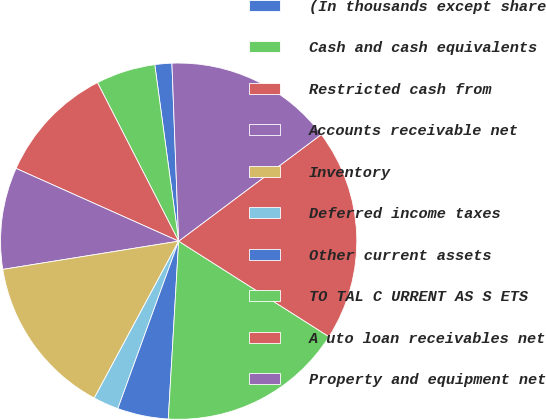<chart> <loc_0><loc_0><loc_500><loc_500><pie_chart><fcel>(In thousands except share<fcel>Cash and cash equivalents<fcel>Restricted cash from<fcel>Accounts receivable net<fcel>Inventory<fcel>Deferred income taxes<fcel>Other current assets<fcel>TO TAL C URRENT AS S ETS<fcel>A uto loan receivables net<fcel>Property and equipment net<nl><fcel>1.54%<fcel>5.39%<fcel>10.77%<fcel>9.23%<fcel>14.61%<fcel>2.31%<fcel>4.62%<fcel>16.92%<fcel>19.23%<fcel>15.38%<nl></chart> 